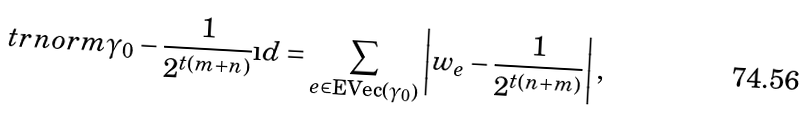Convert formula to latex. <formula><loc_0><loc_0><loc_500><loc_500>\ t r n o r m { \gamma _ { 0 } - \frac { 1 } { 2 ^ { t ( m + n ) } } \i d } = \sum _ { e \in \text {EVec} ( \gamma _ { 0 } ) } \left | w _ { e } - \frac { 1 } { 2 ^ { t ( n + m ) } } \right | ,</formula> 